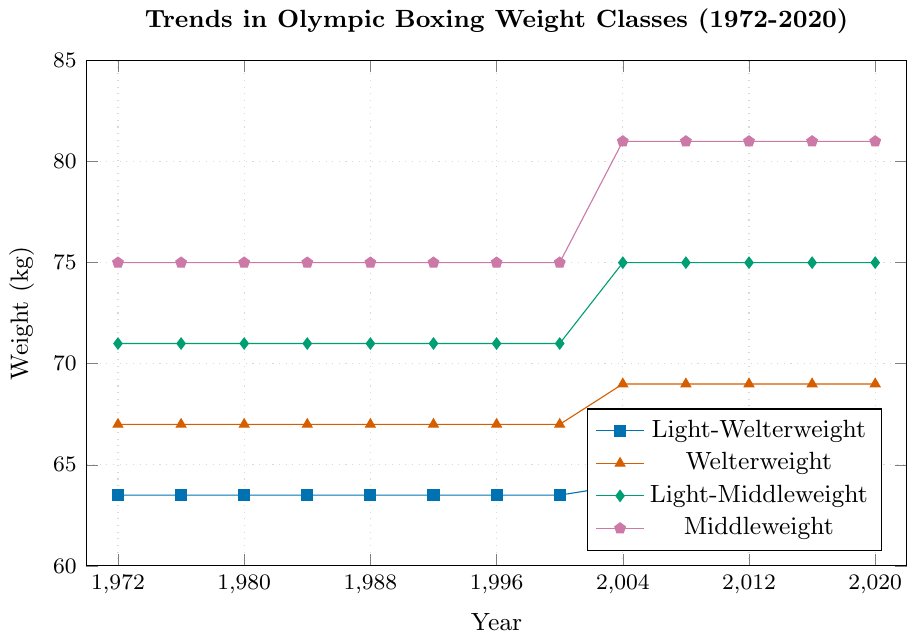Which weight classes saw a change between 2000 and 2004? Compare the weights in 2000 and 2004 for each weight class. Light-Welterweight changed from 63.5 kg to 64 kg, Welterweight from 67 kg to 69 kg, Light-Middleweight from 71 kg to 75 kg, and Middleweight from 75 kg to 81 kg.
Answer: Light-Welterweight, Welterweight, Light-Middleweight, Middleweight What happened to the Light-Welterweight class in 2020? Look at the weight of the Light-Welterweight class in 2020, which dropped from 64 kg to 63 kg.
Answer: It decreased to 63 kg What's the difference in Welterweight class weight between its introduction and the most recent year? Compare the weight of the Welterweight class in 1972 (67 kg) with that in 2020 (69 kg) and find the difference.
Answer: 2 kg On average, how much has the Middleweight class weight increased since its introduction in 1972? Calculate the difference between the weight in 1972 (75 kg) and in 2020 (81 kg), then find the average increase per year over the 48 years.
Answer: 6 kg over 48 years Which weight class has undergone the most significant change over the years? Compare the changes in weight for each class from 1972 to 2020. Middleweight increased the most, from 75 kg to 81 kg (6 kg).
Answer: Middleweight Between 2004 and 2016, which weight class saw the smallest change? Compare the weights in 2004 and 2016 for each class. All weights stayed the same during this period, so the change is zero for all classes.
Answer: None How much did the Light-Welterweight class weight decrease from 2016 to 2020? Subtract the weight in 2020 (63 kg) from the weight in 2016 (64 kg).
Answer: 1 kg What is the trend for the Welterweight class from 1972 to 2020? Observe the weights for the Welterweight class over the years; they increased from 67 kg to 69 kg.
Answer: Increasing How often did the Light-Middleweight class weight change? Note the years when the Light-Middleweight class weight changed: 1972 to 2000 at 71 kg, changed in 2004 to 75 kg, and stayed the same afterwards.
Answer: Once What is the total weight change for all weight classes combined from 1972 to 2020? Calculate the sum of changes for each weight class: Light-Welterweight (63.5 to 63, -0.5 kg), Welterweight (67 to 69, +2 kg), Light-Middleweight (71 to 75, +4 kg), and Middleweight (75 to 81, +6 kg). Sum these changes (-0.5 + 2 + 4 + 6).
Answer: 11.5 kg 